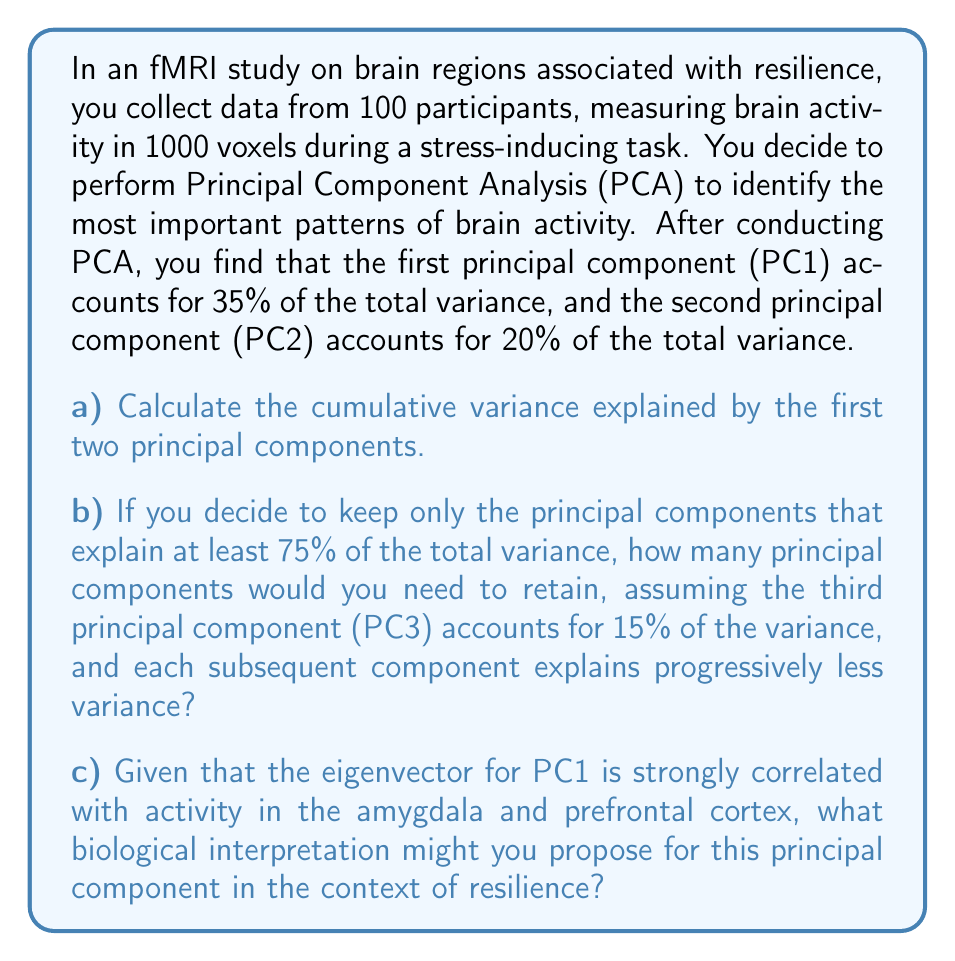Give your solution to this math problem. Let's break this down step by step:

a) To calculate the cumulative variance explained by the first two principal components, we simply add their individual contributions:

$$ \text{Cumulative Variance} = \text{Variance}_{\text{PC1}} + \text{Variance}_{\text{PC2}} $$
$$ \text{Cumulative Variance} = 35\% + 20\% = 55\% $$

b) To determine how many principal components to retain, we need to add up the variance explained by each component until we reach or exceed 75%:

$$ \text{PC1} + \text{PC2} + \text{PC3} = 35\% + 20\% + 15\% = 70\% $$

This is not enough, so we need to include at least one more component. Since each subsequent component explains progressively less variance, we can assume that PC4 will explain enough to reach or exceed 75%.

c) The biological interpretation of PC1 being strongly correlated with activity in the amygdala and prefrontal cortex can be related to the neuroscience of resilience:

The amygdala is involved in emotional processing, particularly fear and stress responses. The prefrontal cortex is associated with executive functions, including emotion regulation and cognitive control. A strong correlation between these regions in PC1 suggests that the most significant pattern of brain activity during the stress-inducing task involves the interplay between emotional processing (amygdala) and cognitive control (prefrontal cortex).

In the context of resilience, this pattern could represent the neural basis of emotion regulation strategies. Individuals with higher resilience may show stronger connectivity or coordinated activity between these regions, allowing them to effectively manage emotional responses to stress through top-down control from the prefrontal cortex to the amygdala.
Answer: a) The cumulative variance explained by the first two principal components is 55%.

b) At least 4 principal components would need to be retained to explain 75% or more of the total variance.

c) PC1 likely represents the neural basis of emotion regulation in resilience, reflecting the interplay between emotional processing in the amygdala and cognitive control from the prefrontal cortex. 